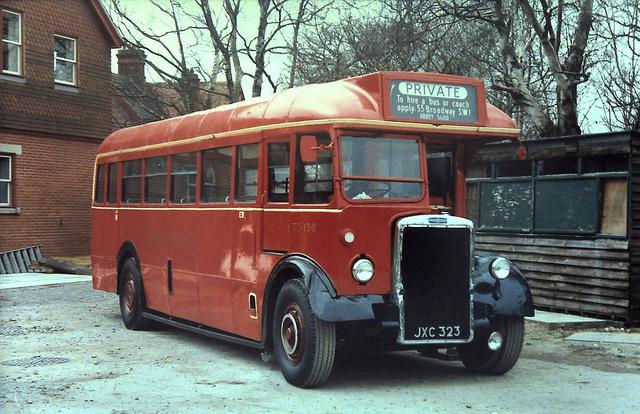How many buses are there?
Write a very short answer. 1. Is this a public bus?
Keep it brief. No. Does this bus have a modern design?
Short answer required. No. Does the bus have a silver roof?
Short answer required. No. Is the bus old?
Concise answer only. Yes. 